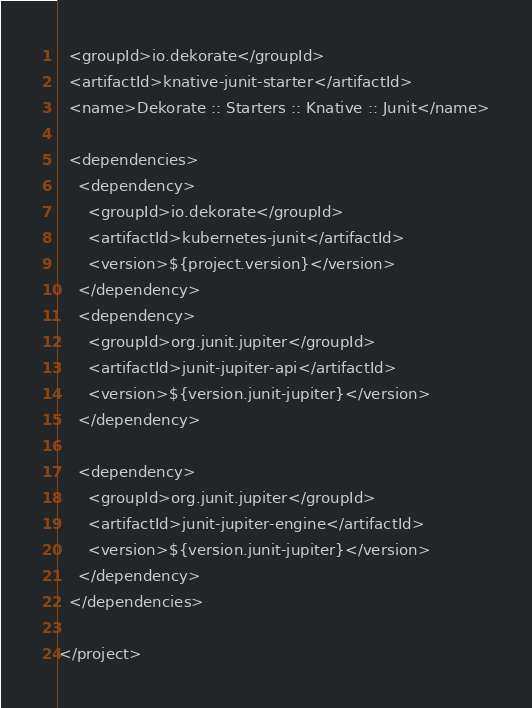<code> <loc_0><loc_0><loc_500><loc_500><_XML_>  <groupId>io.dekorate</groupId>
  <artifactId>knative-junit-starter</artifactId>
  <name>Dekorate :: Starters :: Knative :: Junit</name>

  <dependencies>
    <dependency>
      <groupId>io.dekorate</groupId>
      <artifactId>kubernetes-junit</artifactId>
      <version>${project.version}</version>
    </dependency>
    <dependency>
      <groupId>org.junit.jupiter</groupId>
      <artifactId>junit-jupiter-api</artifactId>
      <version>${version.junit-jupiter}</version>
    </dependency>

    <dependency>
      <groupId>org.junit.jupiter</groupId>
      <artifactId>junit-jupiter-engine</artifactId>
      <version>${version.junit-jupiter}</version>
    </dependency>
  </dependencies>

</project>
</code> 